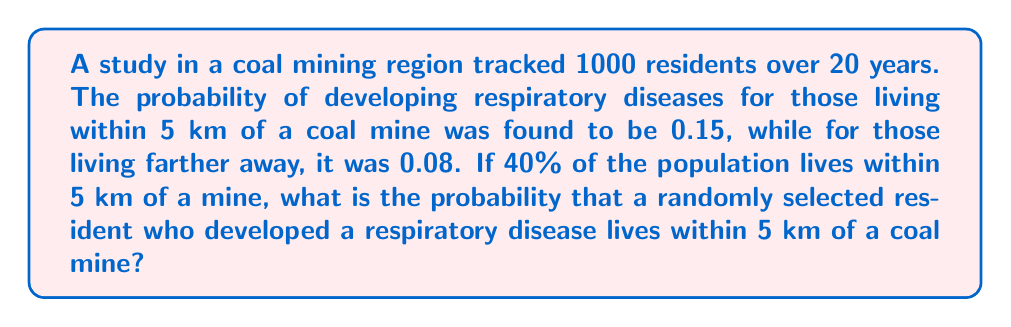Solve this math problem. Let's approach this step-by-step using Bayes' theorem:

1) Define events:
   A: Living within 5 km of a coal mine
   B: Developing a respiratory disease

2) Given probabilities:
   P(A) = 0.40 (40% of population lives within 5 km)
   P(B|A) = 0.15 (probability of disease given living within 5 km)
   P(B|not A) = 0.08 (probability of disease given living farther than 5 km)

3) We need to find P(A|B) using Bayes' theorem:

   $$P(A|B) = \frac{P(B|A) \cdot P(A)}{P(B)}$$

4) We need to calculate P(B) using the law of total probability:

   $$P(B) = P(B|A) \cdot P(A) + P(B|not A) \cdot P(not A)$$

5) Calculate P(not A):
   P(not A) = 1 - P(A) = 1 - 0.40 = 0.60

6) Now calculate P(B):
   $$P(B) = 0.15 \cdot 0.40 + 0.08 \cdot 0.60 = 0.06 + 0.048 = 0.108$$

7) Finally, apply Bayes' theorem:

   $$P(A|B) = \frac{0.15 \cdot 0.40}{0.108} = \frac{0.06}{0.108} \approx 0.5556$$
Answer: $\approx 0.5556$ or $55.56\%$ 